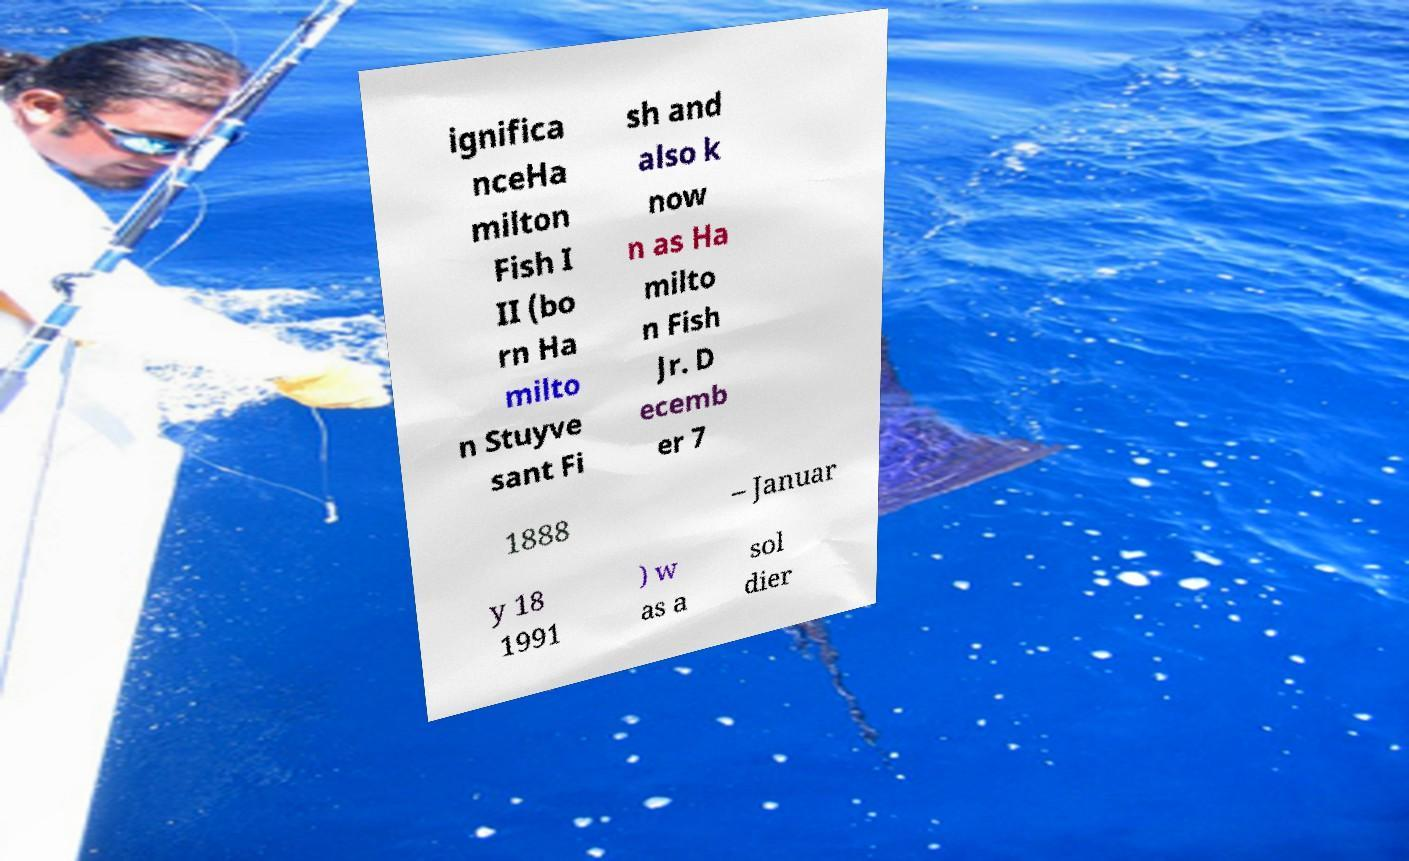Please read and relay the text visible in this image. What does it say? ignifica nceHa milton Fish I II (bo rn Ha milto n Stuyve sant Fi sh and also k now n as Ha milto n Fish Jr. D ecemb er 7 1888 – Januar y 18 1991 ) w as a sol dier 